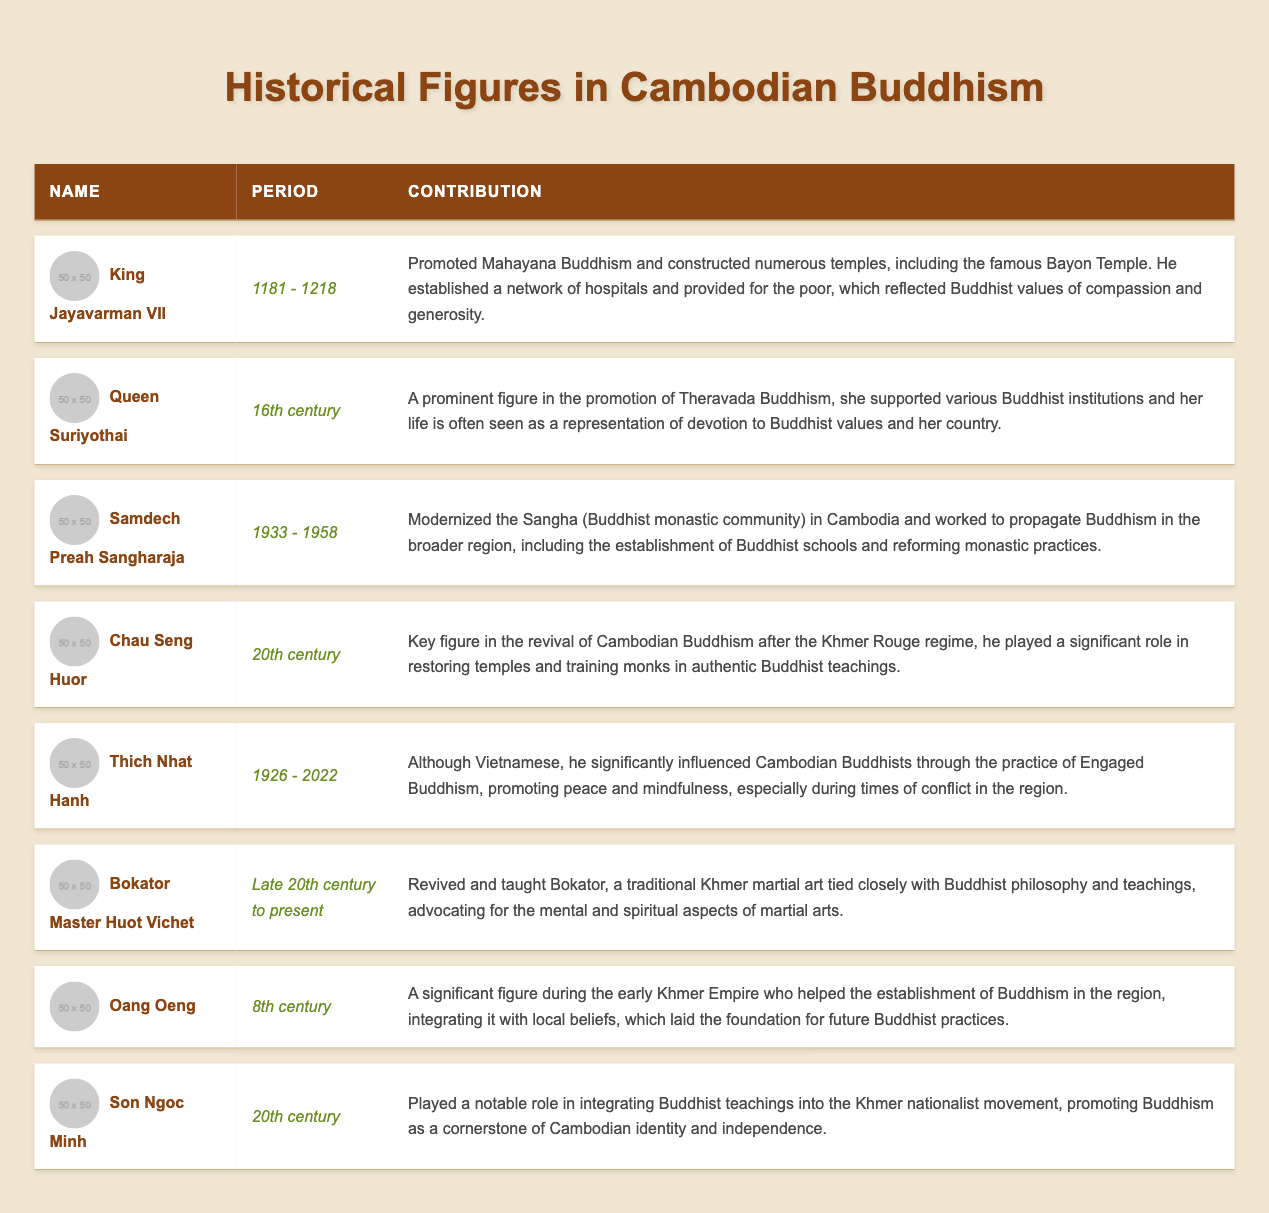What is the contribution of King Jayavarman VII? The table lists King Jayavarman VII's contribution as promoting Mahayana Buddhism and constructing numerous temples, including the famous Bayon Temple. He also established hospitals and provided for the poor, embodying Buddhist values.
Answer: He promoted Mahayana Buddhism and constructed temples, established hospitals, and provided for the poor In which period did Queen Suriyothai contribute to Buddhism? According to the table, Queen Suriyothai is noted to have contributed during the 16th century.
Answer: 16th century Did Samdech Preah Sangharaja modernize the Sangha in Cambodia? The entry for Samdech Preah Sangharaja in the table indicates that he modernized the Sangha and worked on propagating Buddhism. This means that the statement is true.
Answer: Yes Which figure is associated with the revival of Cambodian Buddhism after the Khmer Rouge regime? The table identifies Chau Seng Huor as the key figure in the revival of Cambodian Buddhism after the Khmer Rouge regime, indicating his significant role in restoring temples and training monks.
Answer: Chau Seng Huor How many figures listed contributed in the 20th century? There are three figures in the table who contributed in the 20th century: Chau Seng Huor, Son Ngoc Minh, and Thich Nhat Hanh. Therefore, the total is three.
Answer: Three Was Oang Oeng a significant figure during the early Khmer Empire? The table describes Oang Oeng as a significant figure during the early Khmer Empire who integrated Buddhism with local beliefs, indicating that this statement is true.
Answer: Yes What were the contributions of Thich Nhat Hanh to Cambodian Buddhism? The table states that Thich Nhat Hanh influenced Cambodian Buddhism through Engaged Buddhism, promoting peace and mindfulness during conflicts, demonstrating his impactful contributions.
Answer: He promoted Engaged Buddhism, peace, and mindfulness Who was the first figure to promote Buddhism during the 8th century? The table indicates that Oang Oeng was the significant figure in the 8th century who helped establish Buddhism in the region.
Answer: Oang Oeng 